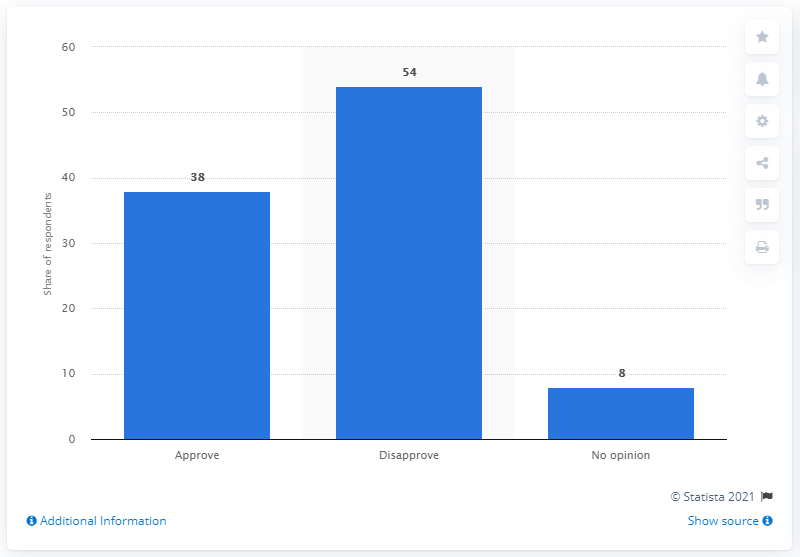Mention a couple of crucial points in this snapshot. In January 2014, 38% of Americans approved of the Affordable Care Act. In January 2014, approximately 54% of Americans disapproved of the Affordable Care Act. 